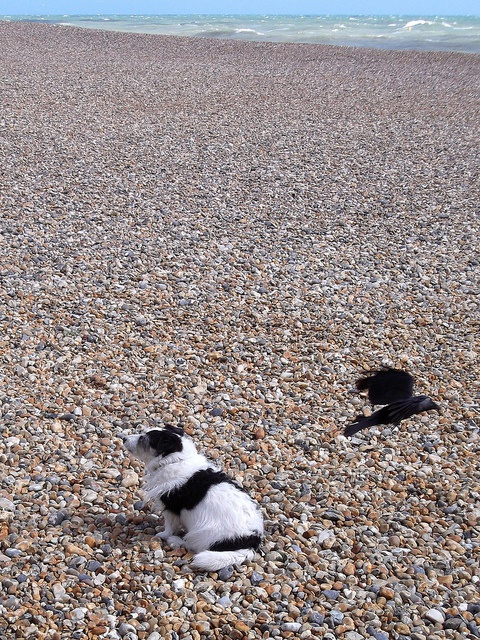Describe the objects in this image and their specific colors. I can see dog in lightblue, lavender, black, darkgray, and gray tones, bird in lightblue, black, gray, and darkgray tones, and bird in lightblue, black, gray, and maroon tones in this image. 